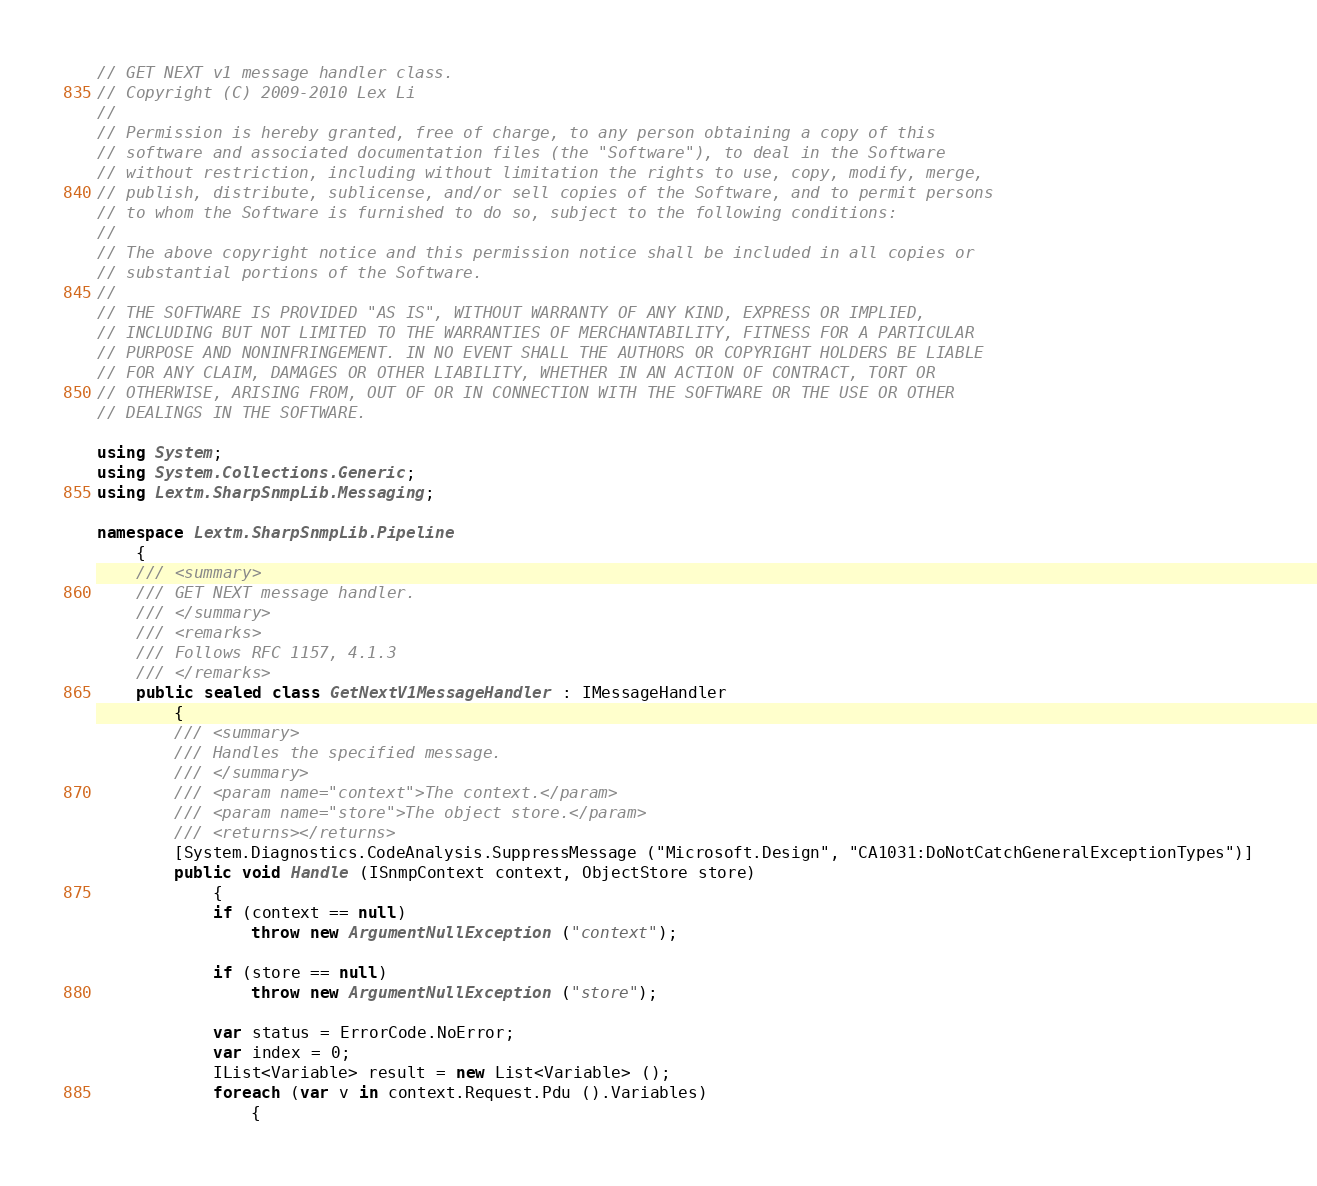Convert code to text. <code><loc_0><loc_0><loc_500><loc_500><_C#_>// GET NEXT v1 message handler class.
// Copyright (C) 2009-2010 Lex Li
// 
// Permission is hereby granted, free of charge, to any person obtaining a copy of this
// software and associated documentation files (the "Software"), to deal in the Software
// without restriction, including without limitation the rights to use, copy, modify, merge,
// publish, distribute, sublicense, and/or sell copies of the Software, and to permit persons
// to whom the Software is furnished to do so, subject to the following conditions:
//
// The above copyright notice and this permission notice shall be included in all copies or
// substantial portions of the Software.
//
// THE SOFTWARE IS PROVIDED "AS IS", WITHOUT WARRANTY OF ANY KIND, EXPRESS OR IMPLIED,
// INCLUDING BUT NOT LIMITED TO THE WARRANTIES OF MERCHANTABILITY, FITNESS FOR A PARTICULAR
// PURPOSE AND NONINFRINGEMENT. IN NO EVENT SHALL THE AUTHORS OR COPYRIGHT HOLDERS BE LIABLE
// FOR ANY CLAIM, DAMAGES OR OTHER LIABILITY, WHETHER IN AN ACTION OF CONTRACT, TORT OR
// OTHERWISE, ARISING FROM, OUT OF OR IN CONNECTION WITH THE SOFTWARE OR THE USE OR OTHER
// DEALINGS IN THE SOFTWARE.

using System;
using System.Collections.Generic;
using Lextm.SharpSnmpLib.Messaging;

namespace Lextm.SharpSnmpLib.Pipeline
	{
	/// <summary>
	/// GET NEXT message handler.
	/// </summary>    
	/// <remarks>
	/// Follows RFC 1157, 4.1.3
	/// </remarks>
	public sealed class GetNextV1MessageHandler : IMessageHandler
		{
		/// <summary>
		/// Handles the specified message.
		/// </summary>
		/// <param name="context">The context.</param>
		/// <param name="store">The object store.</param>
		/// <returns></returns>
		[System.Diagnostics.CodeAnalysis.SuppressMessage ("Microsoft.Design", "CA1031:DoNotCatchGeneralExceptionTypes")]
		public void Handle (ISnmpContext context, ObjectStore store)
			{
			if (context == null)
				throw new ArgumentNullException ("context");

			if (store == null)
				throw new ArgumentNullException ("store");

			var status = ErrorCode.NoError;
			var index = 0;
			IList<Variable> result = new List<Variable> ();
			foreach (var v in context.Request.Pdu ().Variables)
				{</code> 